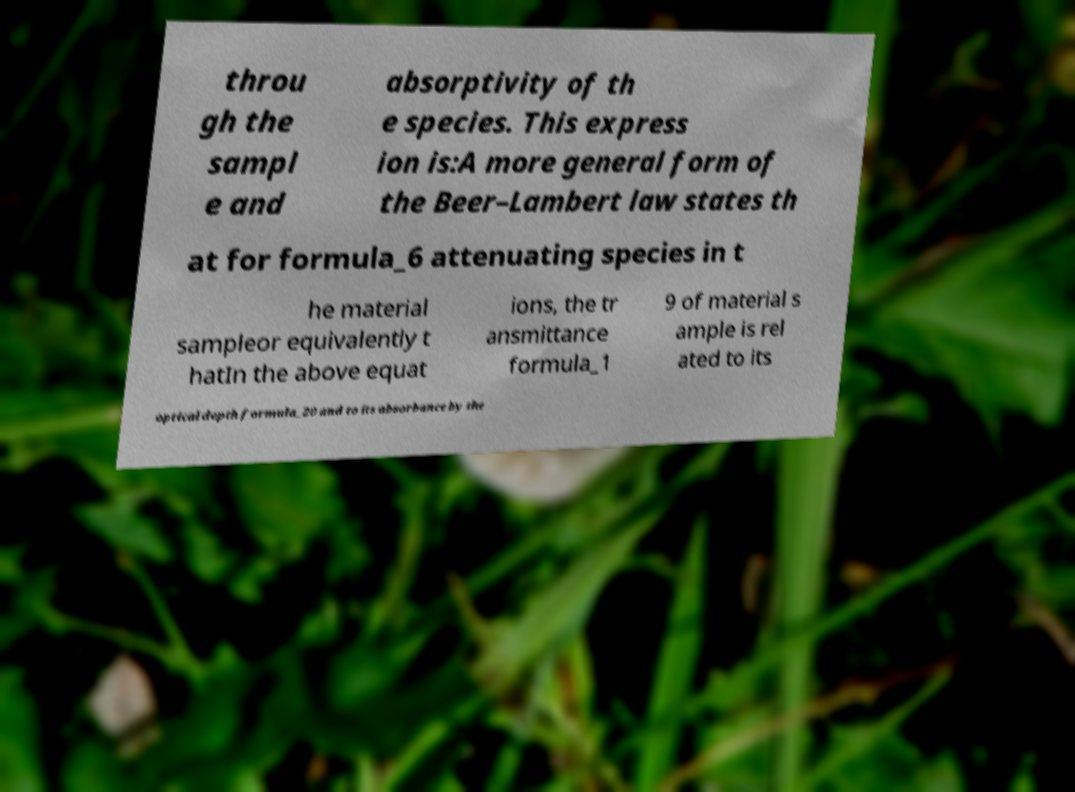Can you accurately transcribe the text from the provided image for me? throu gh the sampl e and absorptivity of th e species. This express ion is:A more general form of the Beer–Lambert law states th at for formula_6 attenuating species in t he material sampleor equivalently t hatIn the above equat ions, the tr ansmittance formula_1 9 of material s ample is rel ated to its optical depth formula_20 and to its absorbance by the 